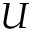<formula> <loc_0><loc_0><loc_500><loc_500>U</formula> 